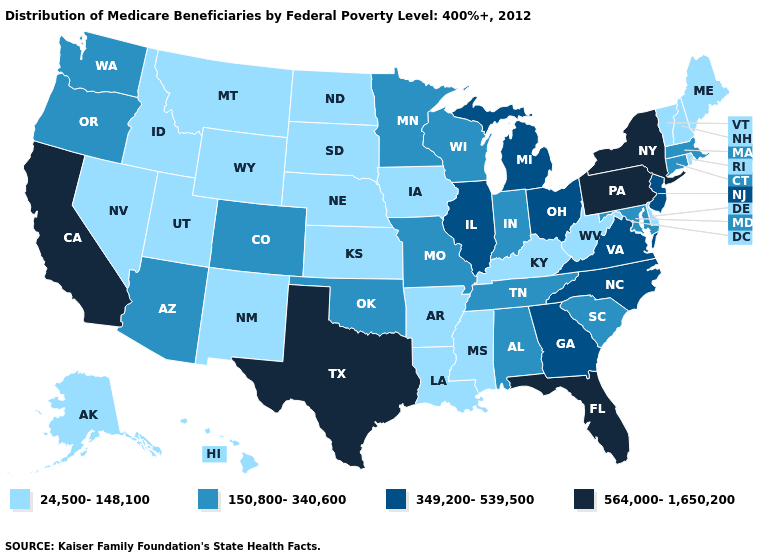Among the states that border Nevada , which have the lowest value?
Keep it brief. Idaho, Utah. What is the value of Montana?
Keep it brief. 24,500-148,100. Does Idaho have a lower value than Arizona?
Write a very short answer. Yes. What is the value of North Dakota?
Quick response, please. 24,500-148,100. What is the value of Kansas?
Write a very short answer. 24,500-148,100. Which states hav the highest value in the MidWest?
Quick response, please. Illinois, Michigan, Ohio. What is the lowest value in the USA?
Keep it brief. 24,500-148,100. Does Vermont have the lowest value in the USA?
Keep it brief. Yes. What is the highest value in the MidWest ?
Concise answer only. 349,200-539,500. What is the value of Connecticut?
Be succinct. 150,800-340,600. Among the states that border California , does Oregon have the highest value?
Give a very brief answer. Yes. What is the value of West Virginia?
Concise answer only. 24,500-148,100. Name the states that have a value in the range 150,800-340,600?
Short answer required. Alabama, Arizona, Colorado, Connecticut, Indiana, Maryland, Massachusetts, Minnesota, Missouri, Oklahoma, Oregon, South Carolina, Tennessee, Washington, Wisconsin. Is the legend a continuous bar?
Be succinct. No. 